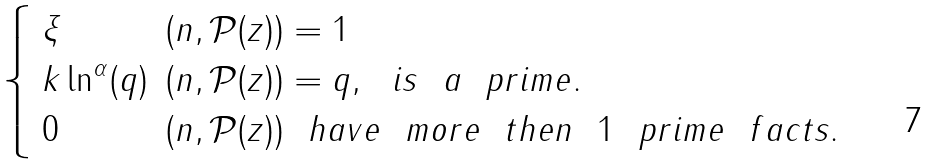<formula> <loc_0><loc_0><loc_500><loc_500>\begin{cases} \begin{array} { l l } \xi & ( n , \mathcal { P } ( z ) ) = 1 \\ k \ln ^ { \alpha } ( q ) & ( n , \mathcal { P } ( z ) ) = q , \ \ i s \ \ a \ \ p r i m e . \\ 0 & ( n , \mathcal { P } ( z ) ) \ \ h a v e \ \ m o r e \ \ t h e n \ \ 1 \ \ p r i m e \ \ f a c t s . \end{array} \end{cases}</formula> 